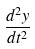Convert formula to latex. <formula><loc_0><loc_0><loc_500><loc_500>\frac { d ^ { 2 } y } { d t ^ { 2 } }</formula> 